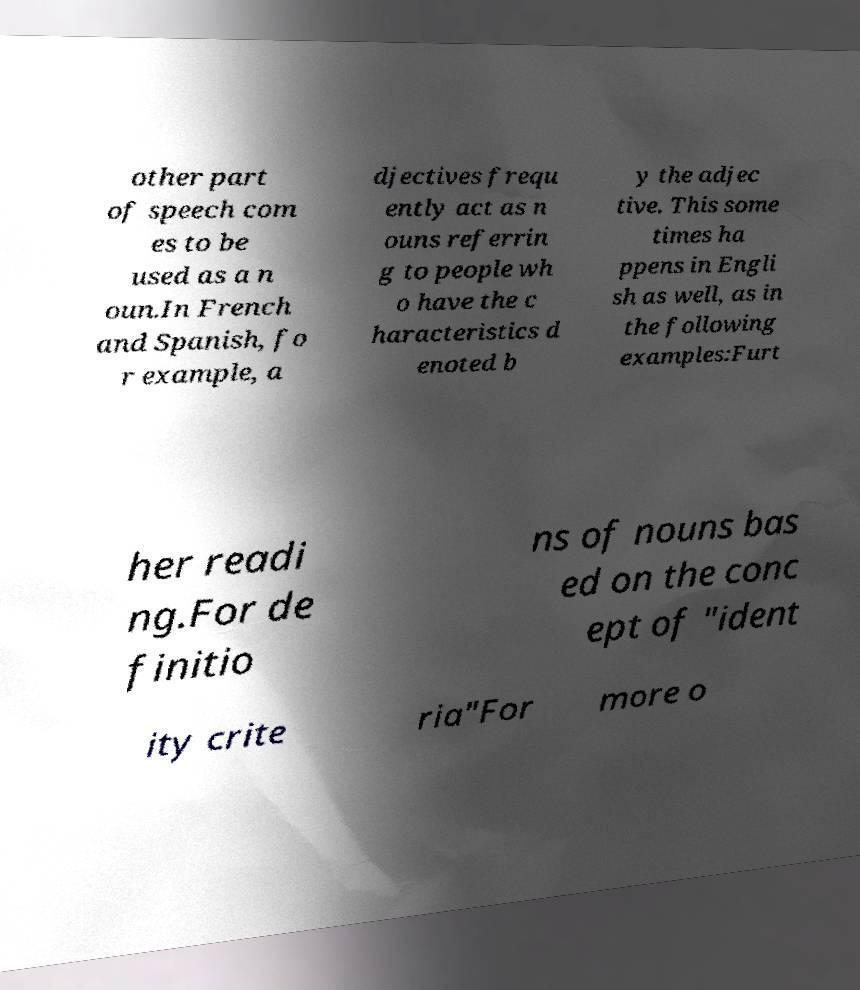Can you read and provide the text displayed in the image?This photo seems to have some interesting text. Can you extract and type it out for me? other part of speech com es to be used as a n oun.In French and Spanish, fo r example, a djectives frequ ently act as n ouns referrin g to people wh o have the c haracteristics d enoted b y the adjec tive. This some times ha ppens in Engli sh as well, as in the following examples:Furt her readi ng.For de finitio ns of nouns bas ed on the conc ept of "ident ity crite ria"For more o 